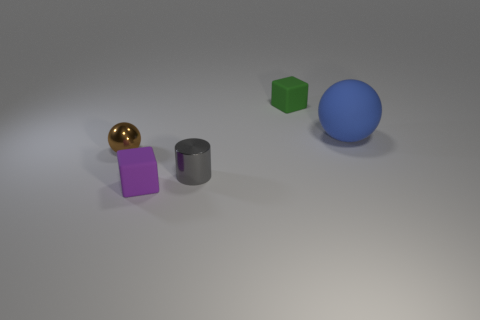Add 4 shiny cylinders. How many objects exist? 9 Subtract all cubes. How many objects are left? 3 Subtract all gray blocks. Subtract all red balls. How many blocks are left? 2 Subtract all purple blocks. Subtract all big red metallic cylinders. How many objects are left? 4 Add 1 brown spheres. How many brown spheres are left? 2 Add 5 tiny brown things. How many tiny brown things exist? 6 Subtract 0 gray blocks. How many objects are left? 5 Subtract 1 cylinders. How many cylinders are left? 0 